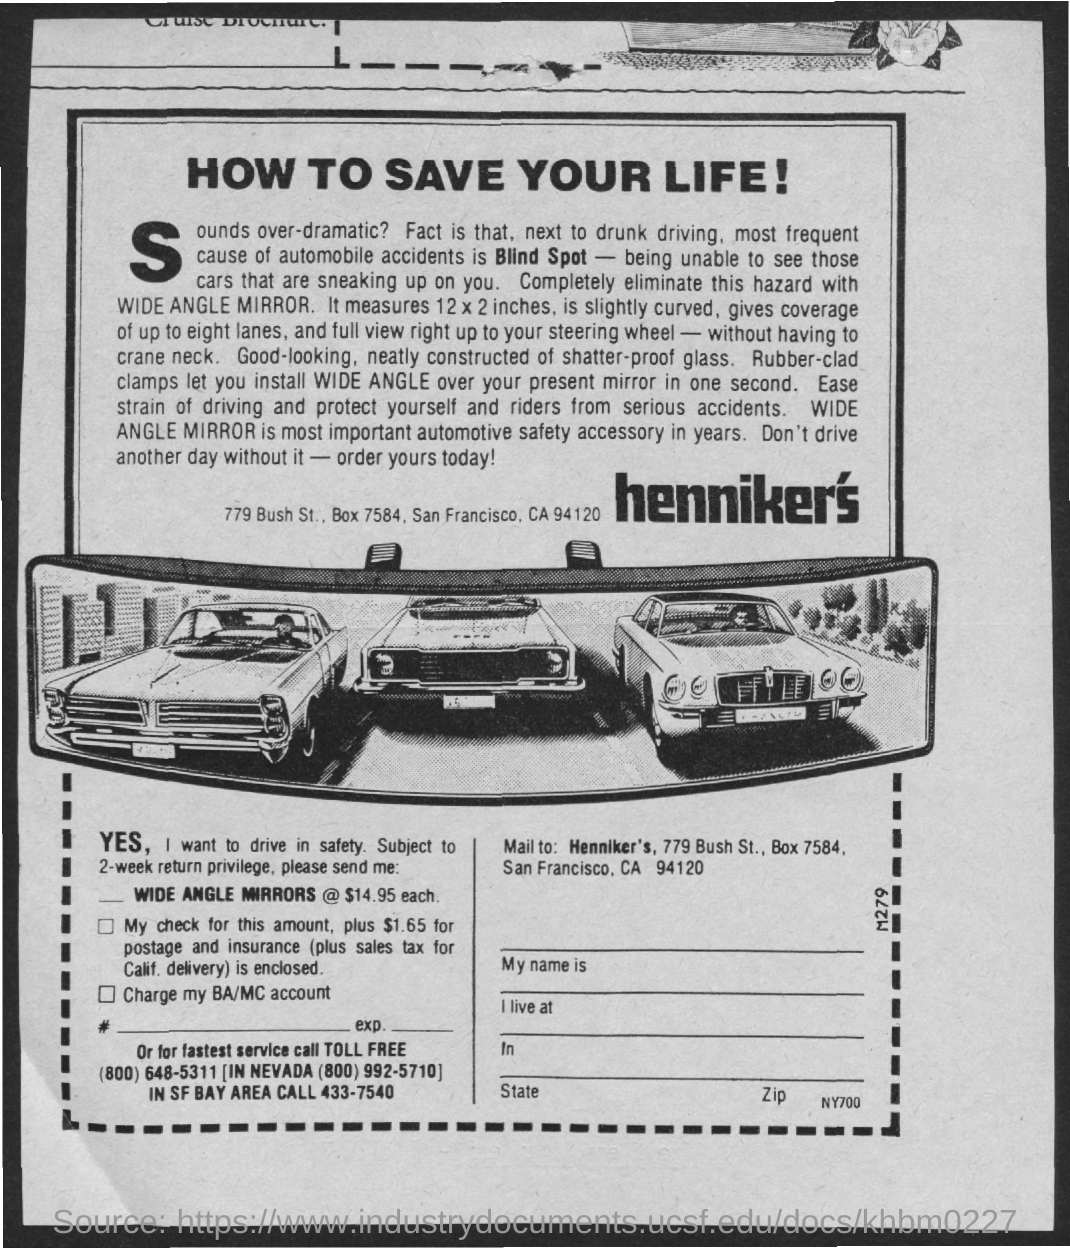What is most frequent cause of automobile accidents?
Offer a terse response. Blind Spot. 